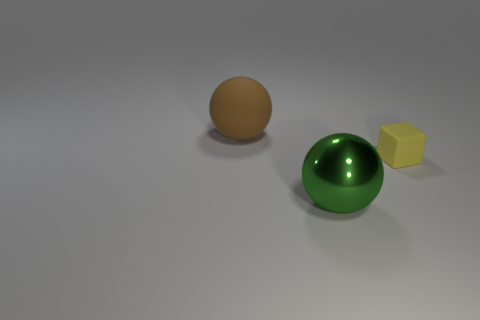Are there any other things that are the same size as the rubber cube?
Your response must be concise. No. Is there anything else that is made of the same material as the green thing?
Make the answer very short. No. Are there any other things that have the same shape as the small yellow object?
Provide a short and direct response. No. How many large balls are made of the same material as the yellow object?
Ensure brevity in your answer.  1. There is a big ball that is in front of the rubber ball behind the green metallic thing; is there a small rubber object that is behind it?
Keep it short and to the point. Yes. What is the shape of the green thing?
Make the answer very short. Sphere. Does the large object that is in front of the small rubber object have the same material as the object behind the small yellow rubber thing?
Provide a succinct answer. No. How many other matte blocks are the same color as the block?
Offer a very short reply. 0. What shape is the thing that is both behind the large metallic sphere and on the left side of the yellow rubber thing?
Your answer should be very brief. Sphere. What is the color of the object that is both behind the green metallic thing and in front of the brown matte object?
Ensure brevity in your answer.  Yellow. 